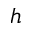<formula> <loc_0><loc_0><loc_500><loc_500>h</formula> 